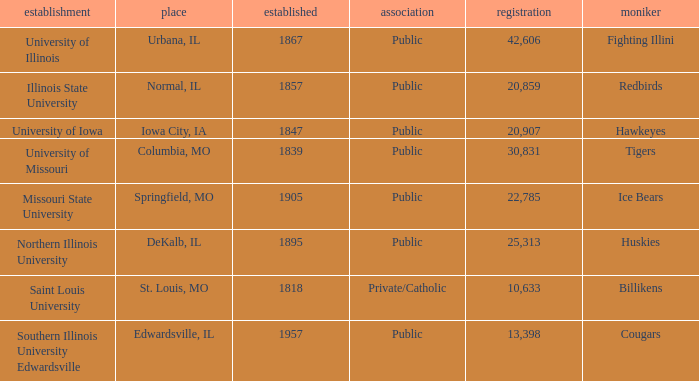What is Southern Illinois University Edwardsville's affiliation? Public. 